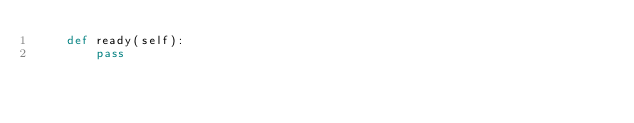Convert code to text. <code><loc_0><loc_0><loc_500><loc_500><_Python_>    def ready(self):
        pass
</code> 